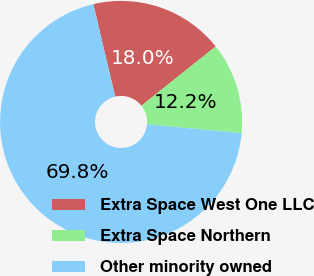Convert chart to OTSL. <chart><loc_0><loc_0><loc_500><loc_500><pie_chart><fcel>Extra Space West One LLC<fcel>Extra Space Northern<fcel>Other minority owned<nl><fcel>17.96%<fcel>12.2%<fcel>69.84%<nl></chart> 